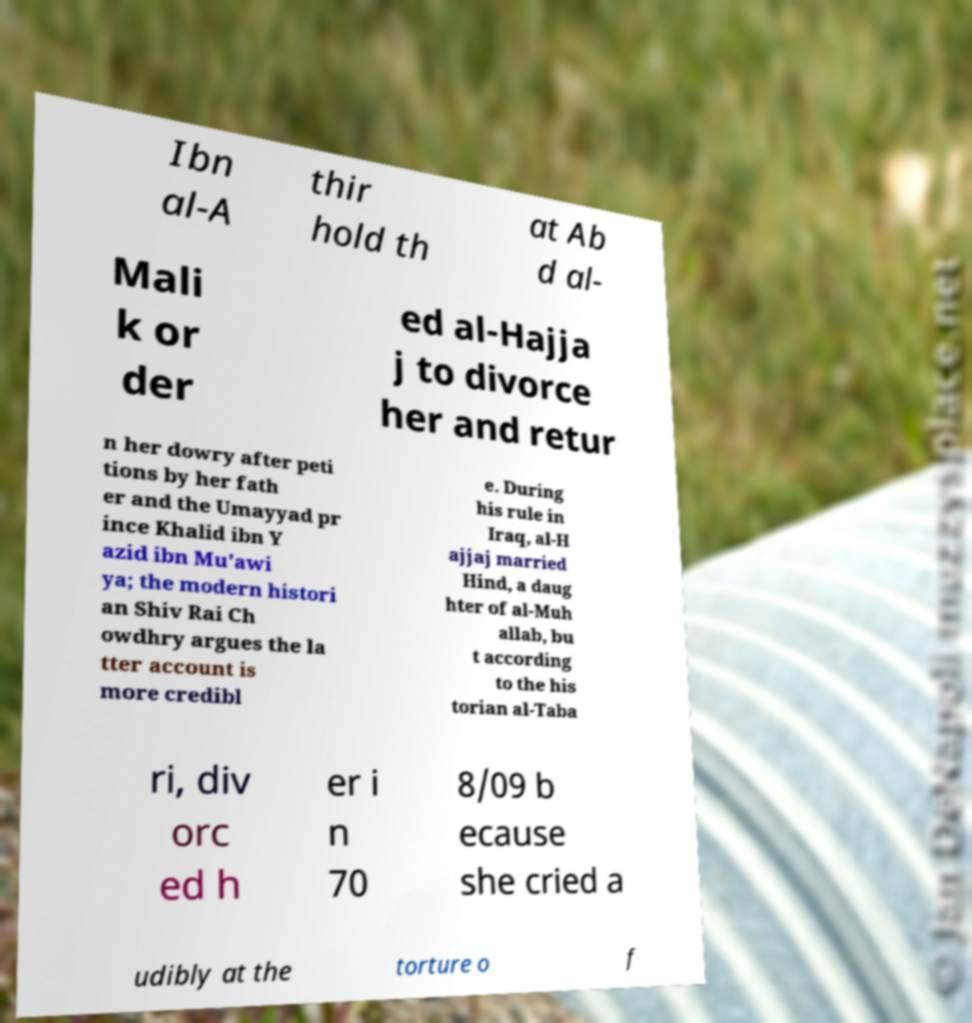Can you accurately transcribe the text from the provided image for me? Ibn al-A thir hold th at Ab d al- Mali k or der ed al-Hajja j to divorce her and retur n her dowry after peti tions by her fath er and the Umayyad pr ince Khalid ibn Y azid ibn Mu'awi ya; the modern histori an Shiv Rai Ch owdhry argues the la tter account is more credibl e. During his rule in Iraq, al-H ajjaj married Hind, a daug hter of al-Muh allab, bu t according to the his torian al-Taba ri, div orc ed h er i n 70 8/09 b ecause she cried a udibly at the torture o f 